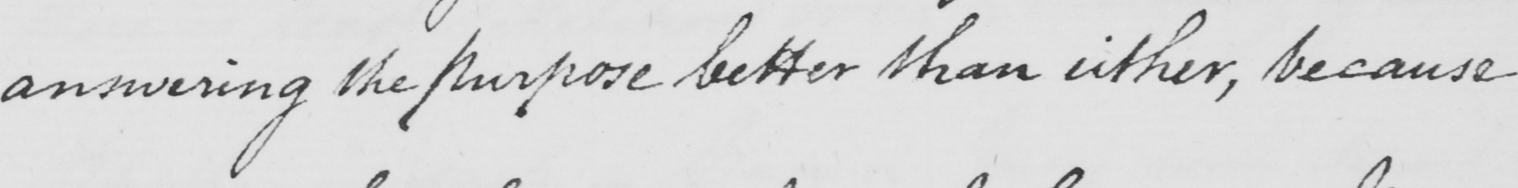Can you read and transcribe this handwriting? answering the purpose better than either , because 